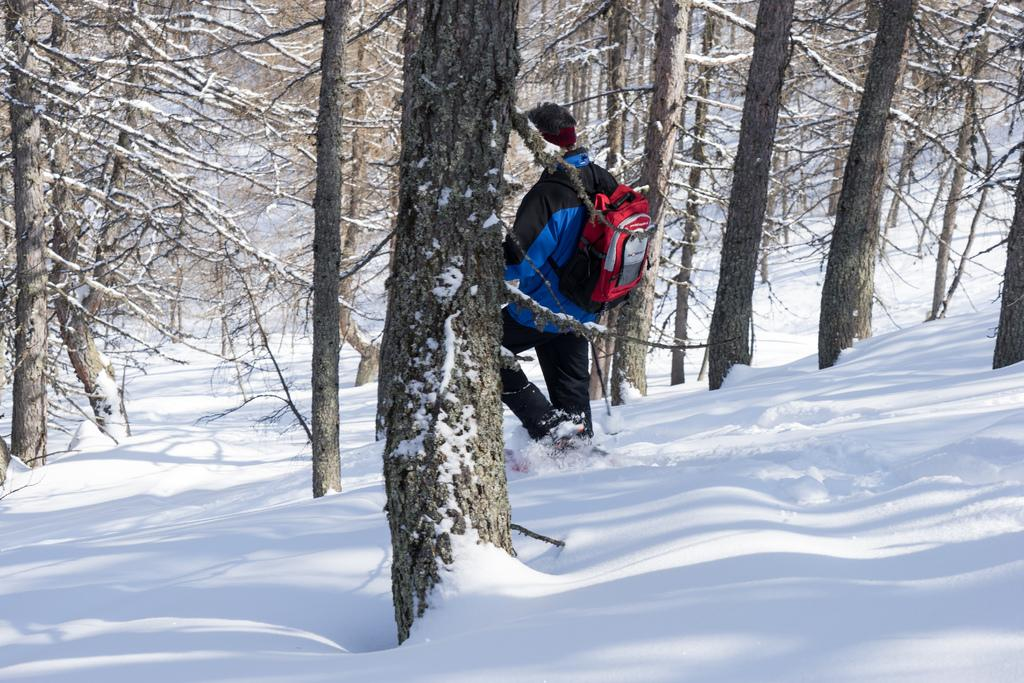What is the main subject of the image? There is a person in the image. What is the person carrying? The person is carrying a bag. What type of terrain is the person walking on? The person is walking on snow. What can be seen in the background of the image? There are trees in the background of the image. What type of writing can be seen on the cow in the image? There is no cow present in the image, so there is no writing on a cow to be seen. 